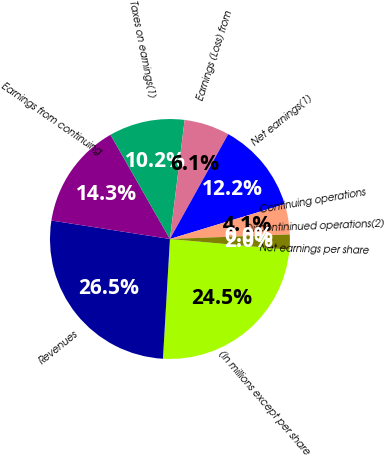<chart> <loc_0><loc_0><loc_500><loc_500><pie_chart><fcel>(In millions except per share<fcel>Revenues<fcel>Earnings from continuing<fcel>Taxes on earnings(1)<fcel>Earnings (Loss) from<fcel>Net earnings(1)<fcel>Continuing operations<fcel>Discontininued operations(2)<fcel>Net earnings per share<nl><fcel>24.49%<fcel>26.53%<fcel>14.29%<fcel>10.2%<fcel>6.12%<fcel>12.24%<fcel>4.08%<fcel>0.0%<fcel>2.04%<nl></chart> 